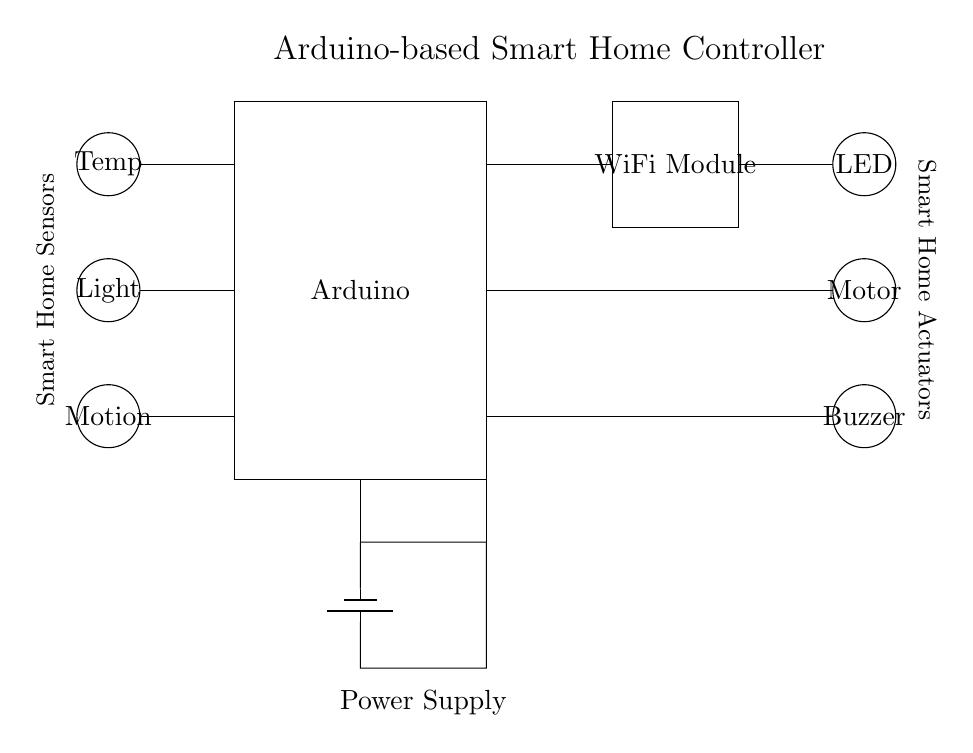What is the main controller in this circuit? The main controller is the Arduino, which is represented in the diagram as a rectangle labeled "Arduino". It is the central component that manages inputs from sensors and outputs to actuators.
Answer: Arduino How many sensors are there? There are three sensors: a temperature sensor, a light sensor, and a motion sensor, which are represented as circles labeled "Temp", "Light", and "Motion". Each sensor is visually distinct and appropriately labeled in the diagram.
Answer: 3 What type of communication module is used? The communication module used in the circuit is a WiFi module, depicted as a rectangle labeled "WiFi Module". It allows the Arduino to connect to a wireless network for remote control and monitoring.
Answer: WiFi Module Which actuator is responsible for sound? The actuator responsible for sound is the buzzer, represented as a circle labeled "Buzzer". It is connected to the Arduino and serves as an output device that produces sound alerts.
Answer: Buzzer What connects the sensors to the Arduino? The sensors are connected to the Arduino through individual wires, indicated by the lines drawn from each sensor to the corresponding pin on the Arduino. This shows direct input connections for the Arduino to receive sensor data.
Answer: Wires Explain the power source in this diagram. The power source is a battery, depicted in the diagram as a symbol for a battery with a connection leading into the Arduino. The power supply provides the necessary voltage for the circuit, supplying energy to all components connected to it.
Answer: Battery What are the three types of actuators shown? The three types of actuators are an LED, a motor, and a buzzer. These are represented as circles labeled "LED", "Motor", and "Buzzer", displaying the different functionalities available for the smart home device controller.
Answer: LED, Motor, Buzzer 